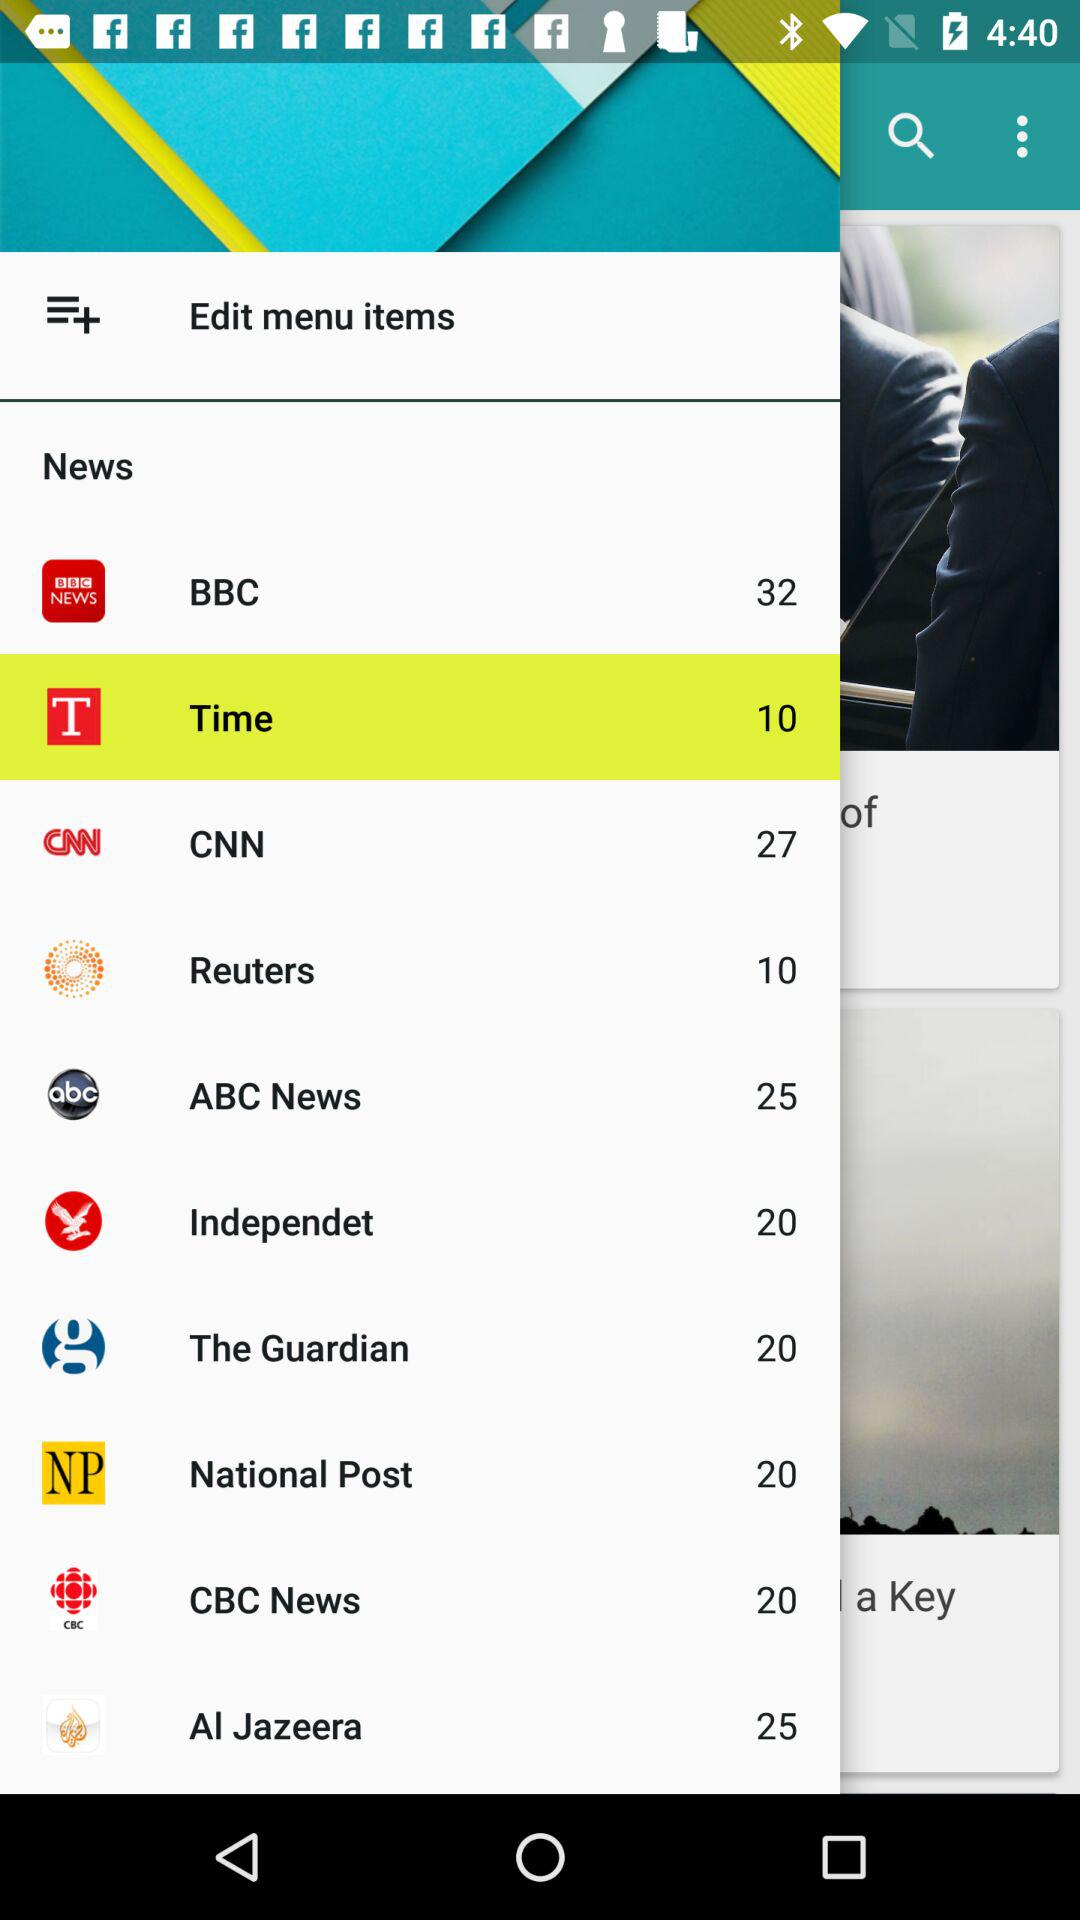How many items are shown in ABC News? In ABC News, there are 25 items displayed. 